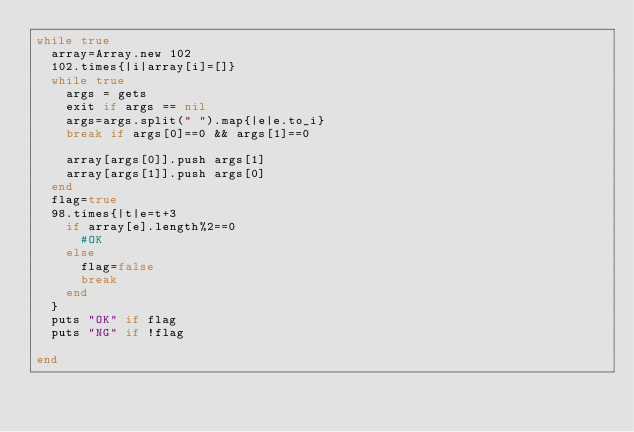Convert code to text. <code><loc_0><loc_0><loc_500><loc_500><_Ruby_>while true
	array=Array.new 102
	102.times{|i|array[i]=[]}
	while true
		args = gets
		exit if args == nil
		args=args.split(" ").map{|e|e.to_i}
		break if args[0]==0 && args[1]==0

		array[args[0]].push args[1]
		array[args[1]].push args[0]
	end
	flag=true
	98.times{|t|e=t+3
		if array[e].length%2==0
			#OK
		else
			flag=false
			break
		end
	}
	puts "OK" if flag
	puts "NG" if !flag

end</code> 